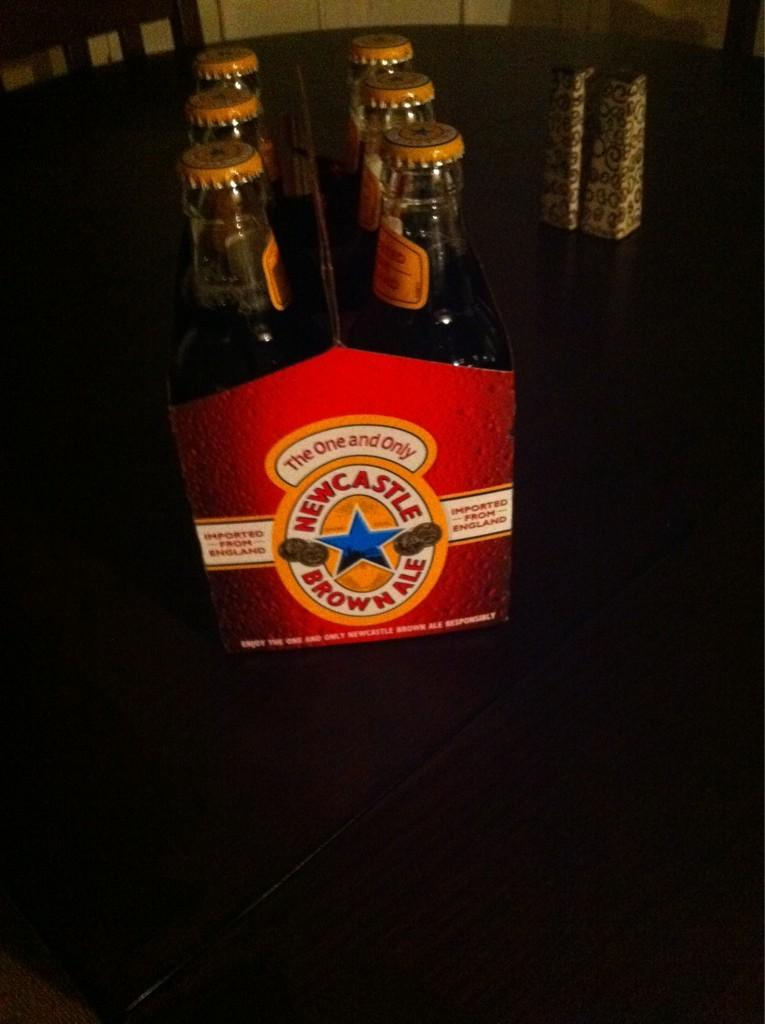<image>
Write a terse but informative summary of the picture. A six pack of bottled beer contains the Newcastle Brown Ale brand. 